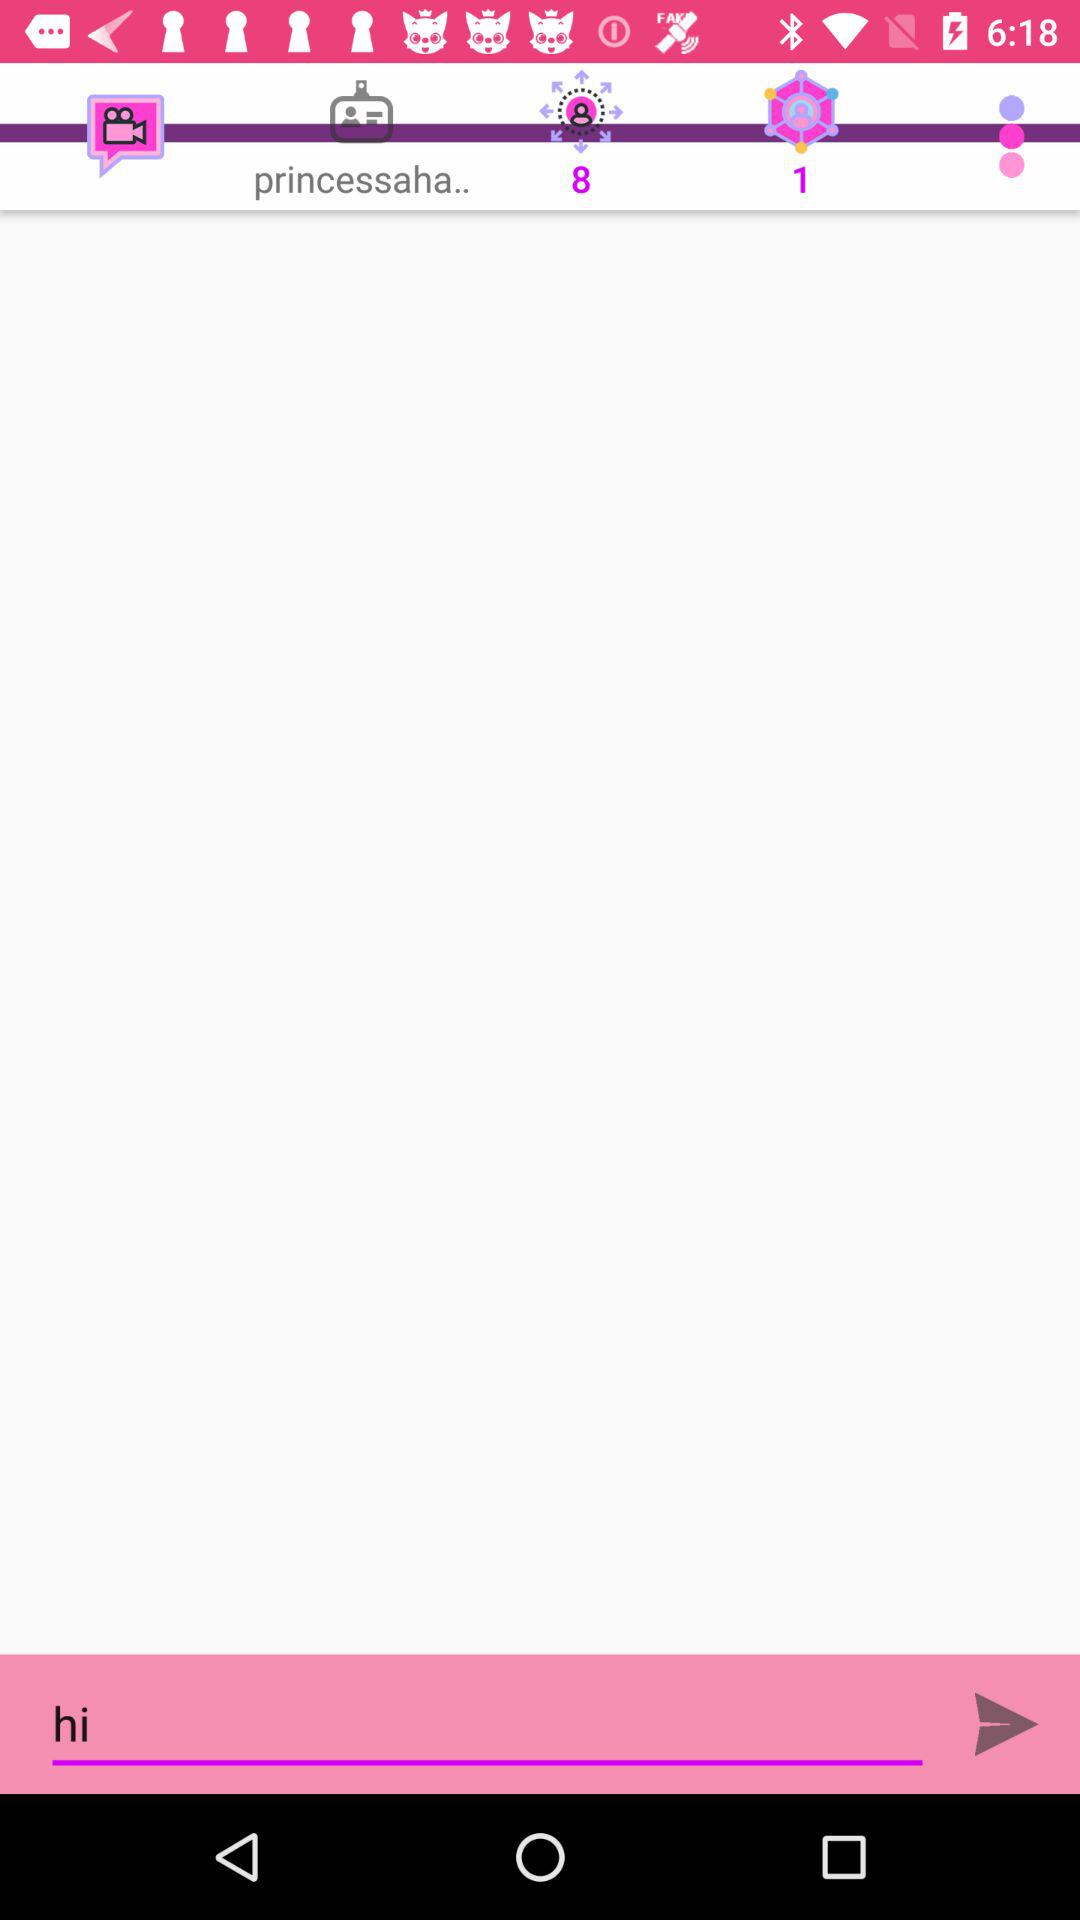What is the text written in the text field? The text written in the text field is "hi". 